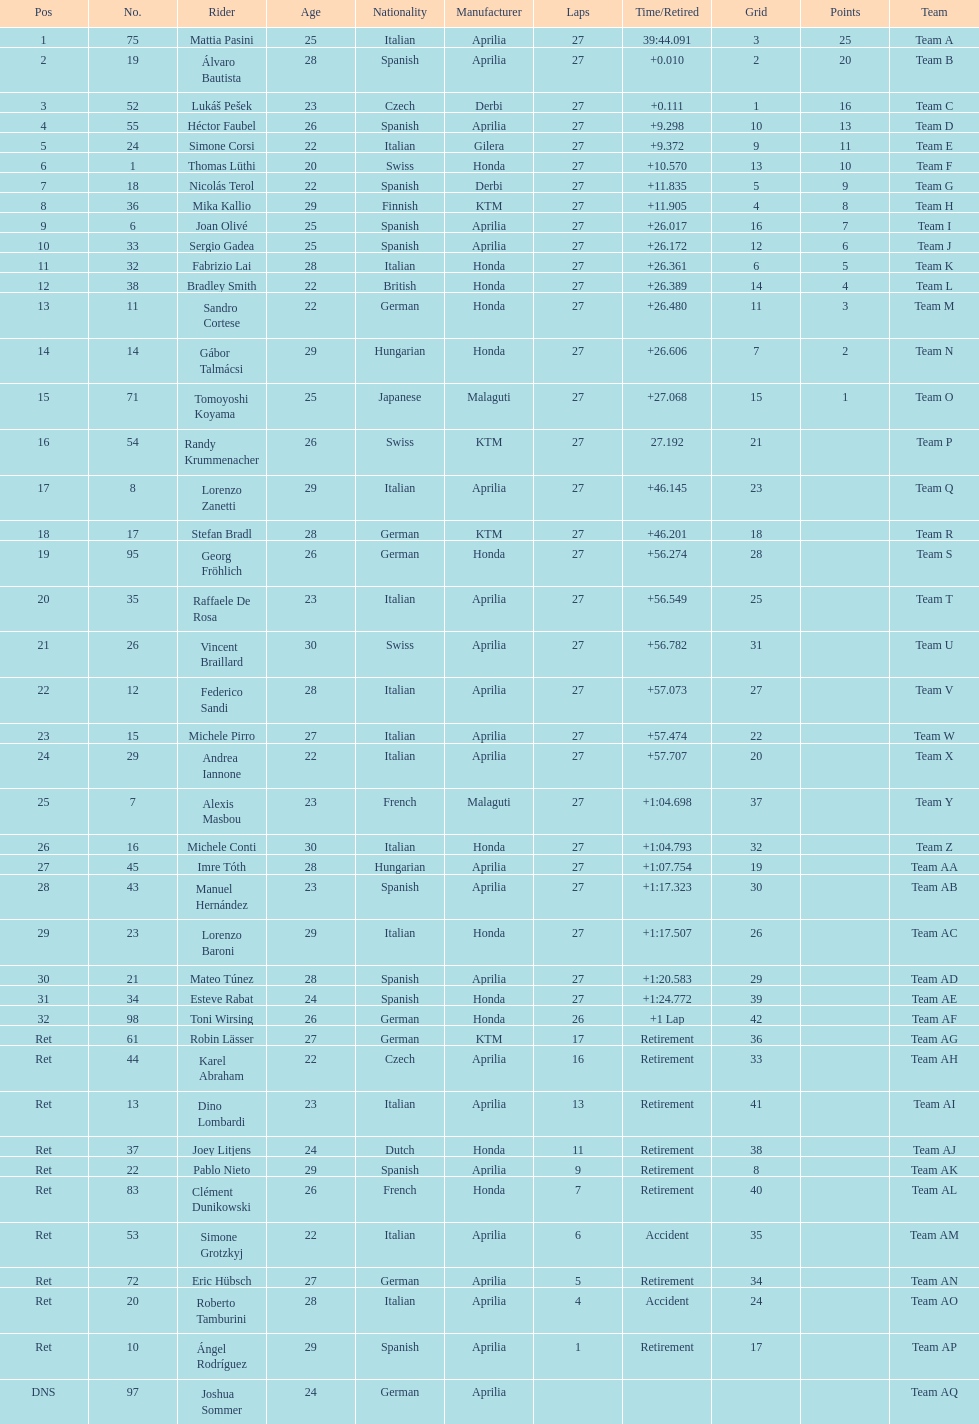How many german racers finished the race? 4. 